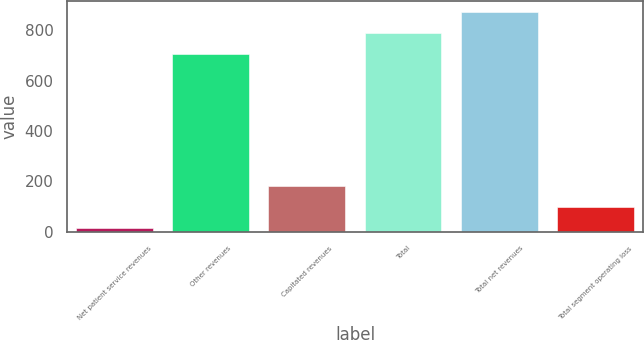<chart> <loc_0><loc_0><loc_500><loc_500><bar_chart><fcel>Net patient service revenues<fcel>Other revenues<fcel>Capitated revenues<fcel>Total<fcel>Total net revenues<fcel>Total segment operating loss<nl><fcel>15<fcel>703<fcel>182.4<fcel>786.7<fcel>870.4<fcel>98.7<nl></chart> 